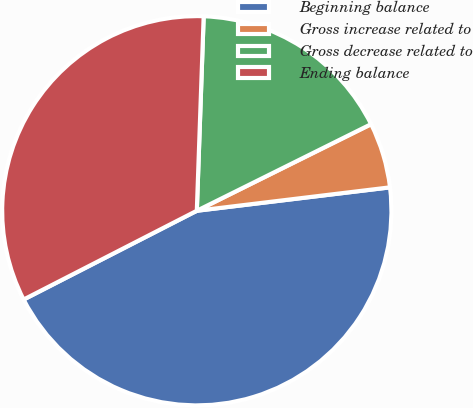Convert chart to OTSL. <chart><loc_0><loc_0><loc_500><loc_500><pie_chart><fcel>Beginning balance<fcel>Gross increase related to<fcel>Gross decrease related to<fcel>Ending balance<nl><fcel>44.38%<fcel>5.42%<fcel>17.1%<fcel>33.1%<nl></chart> 